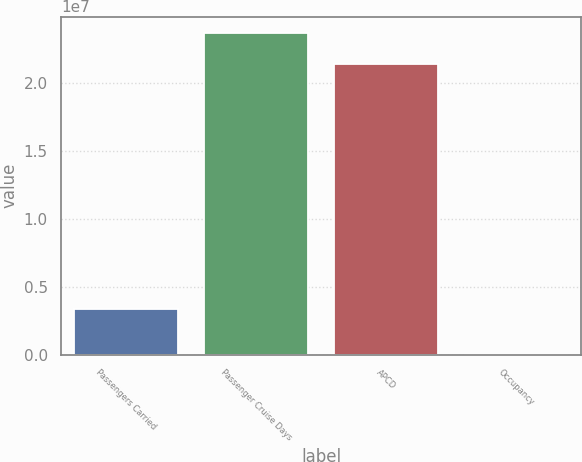Convert chart. <chart><loc_0><loc_0><loc_500><loc_500><bar_chart><fcel>Passengers Carried<fcel>Passenger Cruise Days<fcel>APCD<fcel>Occupancy<nl><fcel>3.40523e+06<fcel>2.37055e+07<fcel>2.14393e+07<fcel>105.7<nl></chart> 